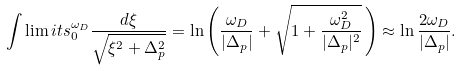<formula> <loc_0><loc_0><loc_500><loc_500>\int \lim i t s _ { 0 } ^ { \omega _ { D } } \frac { d \xi } { \sqrt { \xi ^ { 2 } + \Delta _ { p } ^ { 2 } } } = \ln \left ( \frac { \omega _ { D } } { | \Delta _ { p } | } + \sqrt { 1 + \frac { \omega _ { D } ^ { 2 } } { | \Delta _ { p } | ^ { 2 } } } \, \right ) \approx \ln \frac { 2 \omega _ { D } } { | \Delta _ { p } | } .</formula> 